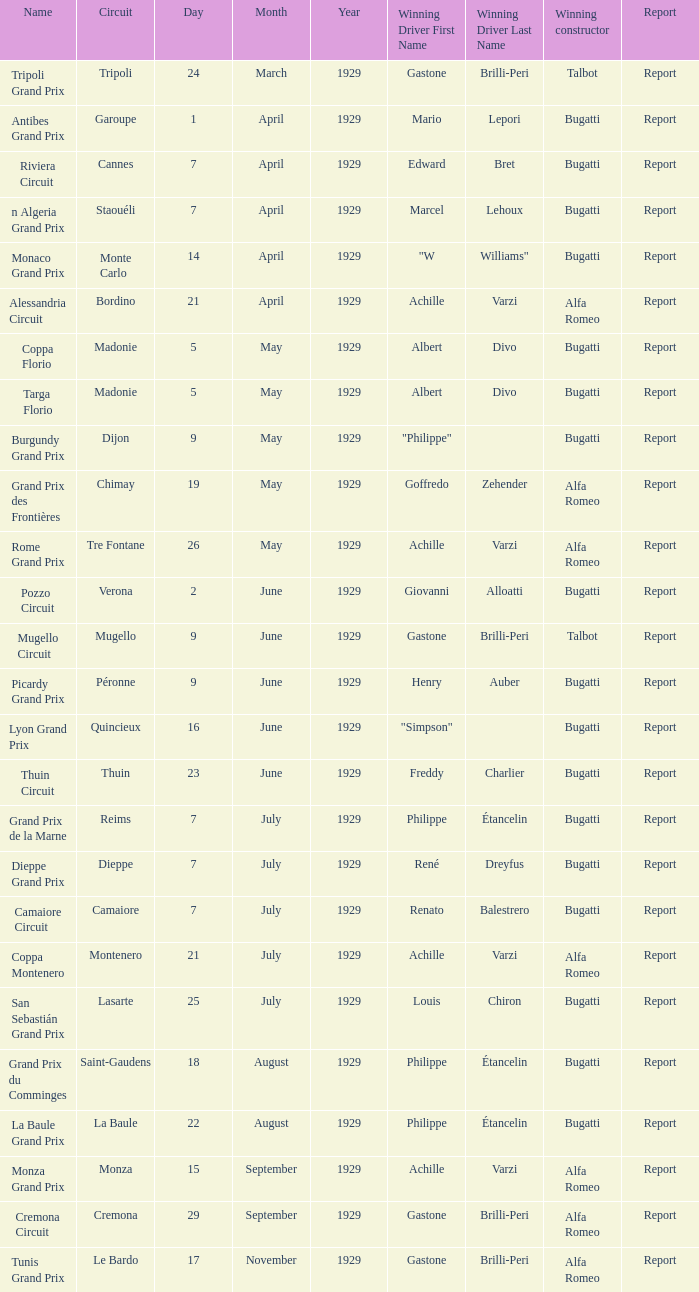What Circuit has a Winning constructor of bugatti, and a Winning driver of edward bret? Cannes. 